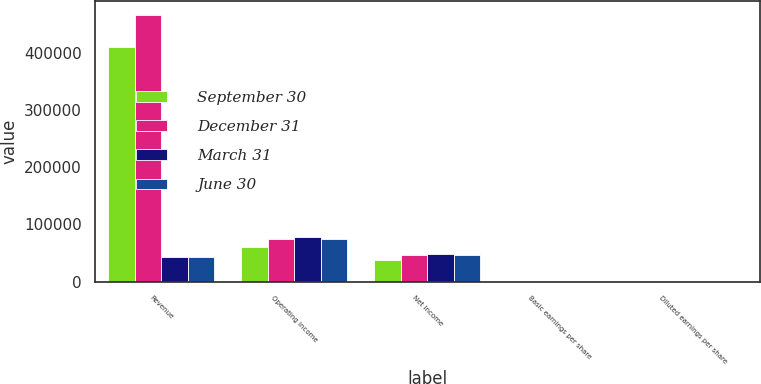Convert chart to OTSL. <chart><loc_0><loc_0><loc_500><loc_500><stacked_bar_chart><ecel><fcel>Revenue<fcel>Operating income<fcel>Net income<fcel>Basic earnings per share<fcel>Diluted earnings per share<nl><fcel>September 30<fcel>409686<fcel>61296<fcel>37847<fcel>1.2<fcel>1.19<nl><fcel>December 31<fcel>466841<fcel>74959<fcel>46461<fcel>1.48<fcel>1.46<nl><fcel>March 31<fcel>42146<fcel>77584<fcel>48228<fcel>1.55<fcel>1.52<nl><fcel>June 30<fcel>42146<fcel>73992<fcel>46445<fcel>1.5<fcel>1.47<nl></chart> 